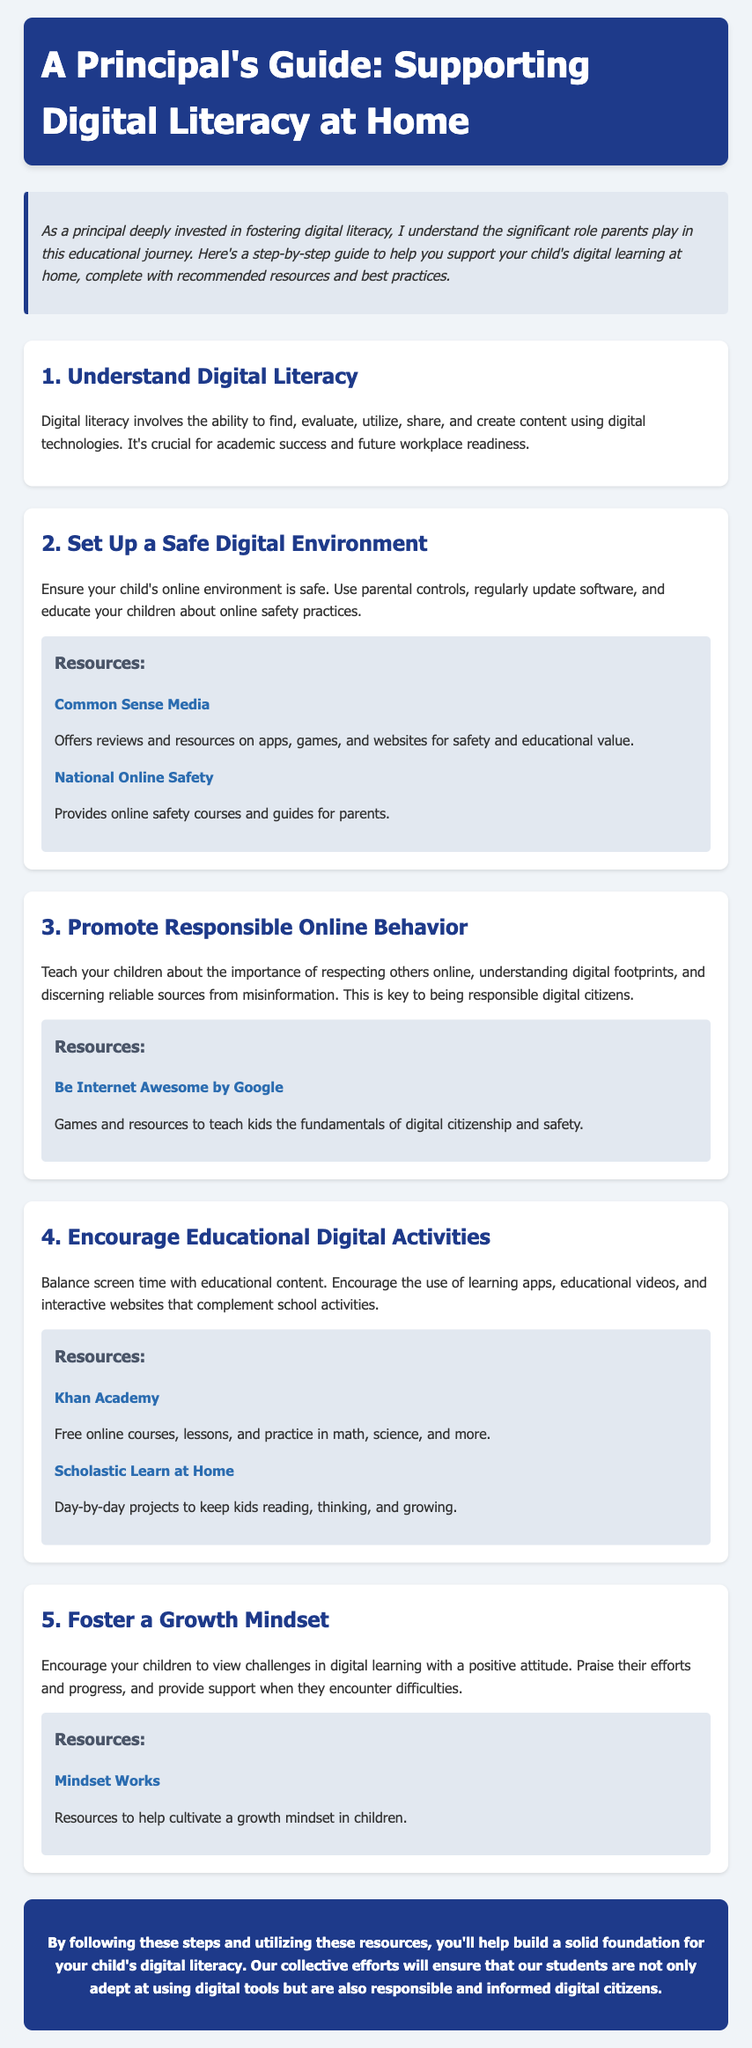What is the title of the guide? The title is found in the header of the document.
Answer: A Principal's Guide: Supporting Digital Literacy at Home How many steps are outlined in the guide? The number of steps is indicated by the headings in the document.
Answer: 5 What is the first step in the guide? The first step is mentioned at the beginning of the steps section.
Answer: Understand Digital Literacy Which resource is recommended for online safety? The resources are listed under various steps, with one specifically addressing online safety.
Answer: Common Sense Media What does promoting responsible online behavior teach children? The purpose of this step is described in the respective section of the document.
Answer: Respecting others online What does the conclusion encourage parents to do? The conclusion summarizes the overall goal of the document.
Answer: Build a solid foundation for digital literacy What organization offers resources to help cultivate a growth mindset? This resource is found under the section promoting a growth mindset.
Answer: Mindset Works What type of activities should be balanced with screen time? The type of activities is discussed in the step about educational digital activities.
Answer: Educational content What is the color of the header background? The color can be inferred from the styling in the document.
Answer: Dark blue 